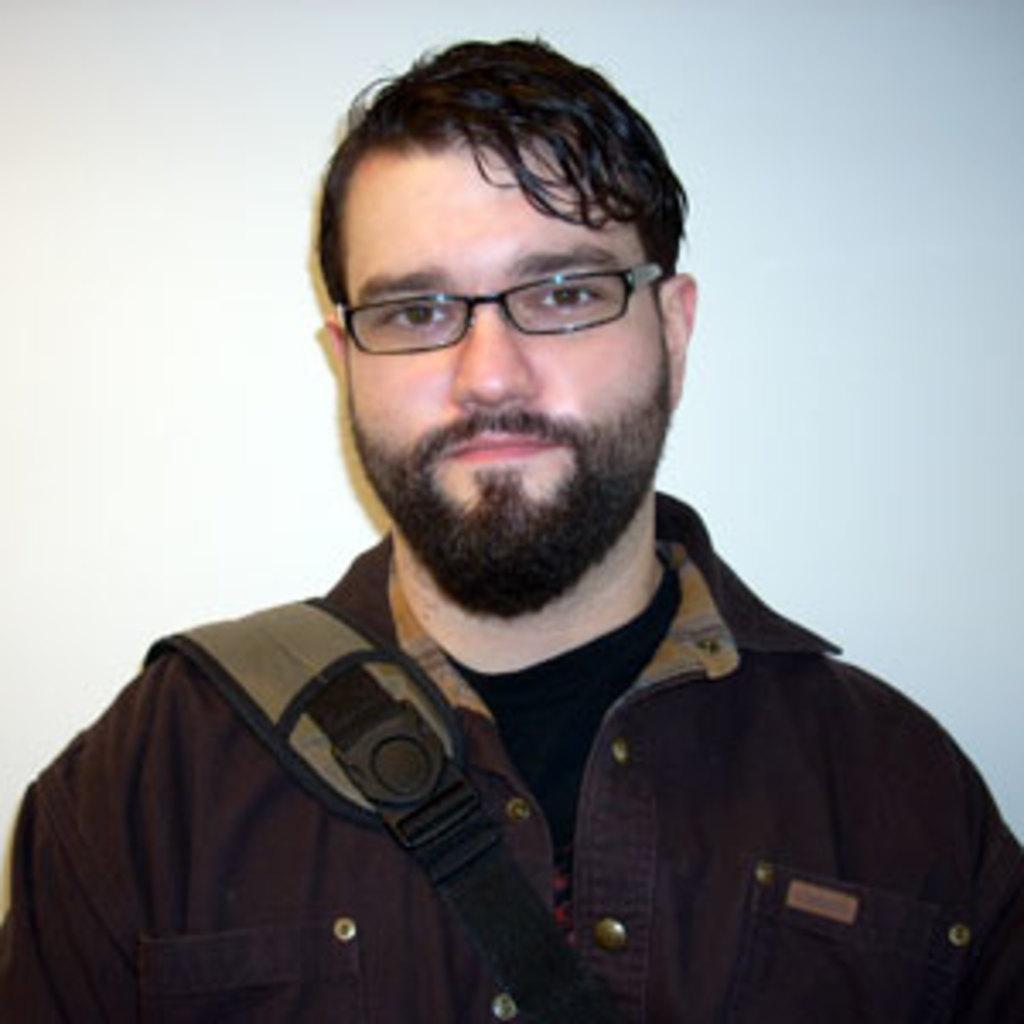How would you summarize this image in a sentence or two? In this picture we can see a man and he wore spectacles. 